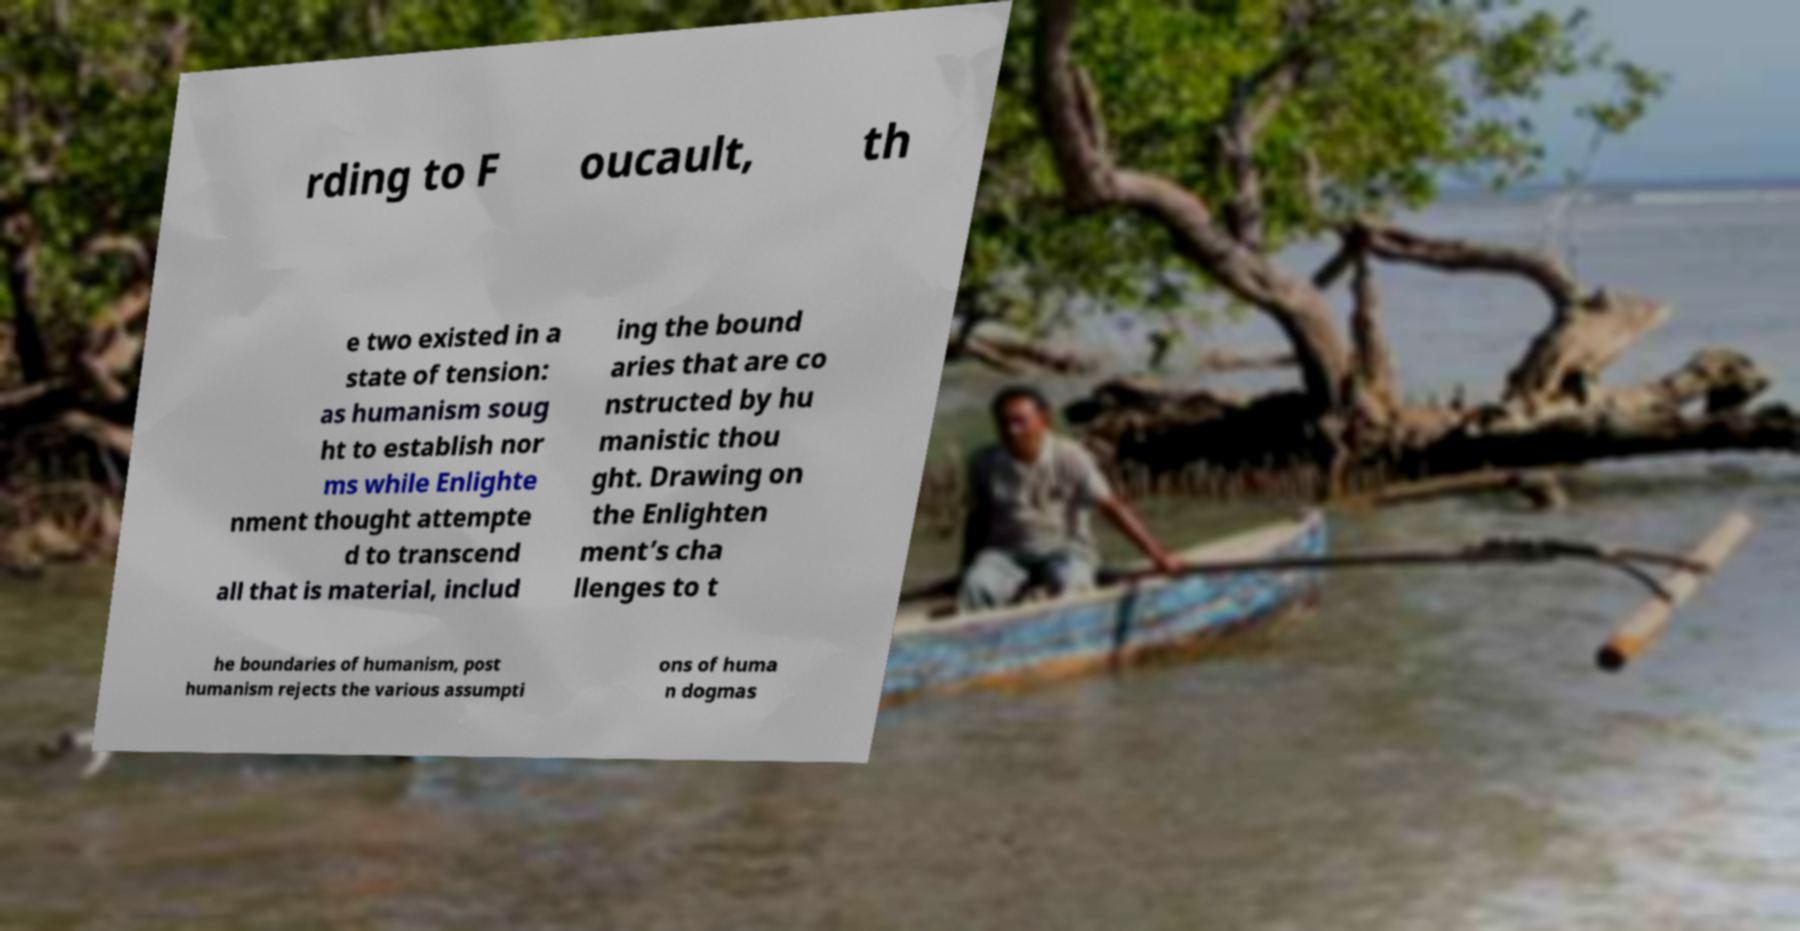What messages or text are displayed in this image? I need them in a readable, typed format. rding to F oucault, th e two existed in a state of tension: as humanism soug ht to establish nor ms while Enlighte nment thought attempte d to transcend all that is material, includ ing the bound aries that are co nstructed by hu manistic thou ght. Drawing on the Enlighten ment’s cha llenges to t he boundaries of humanism, post humanism rejects the various assumpti ons of huma n dogmas 